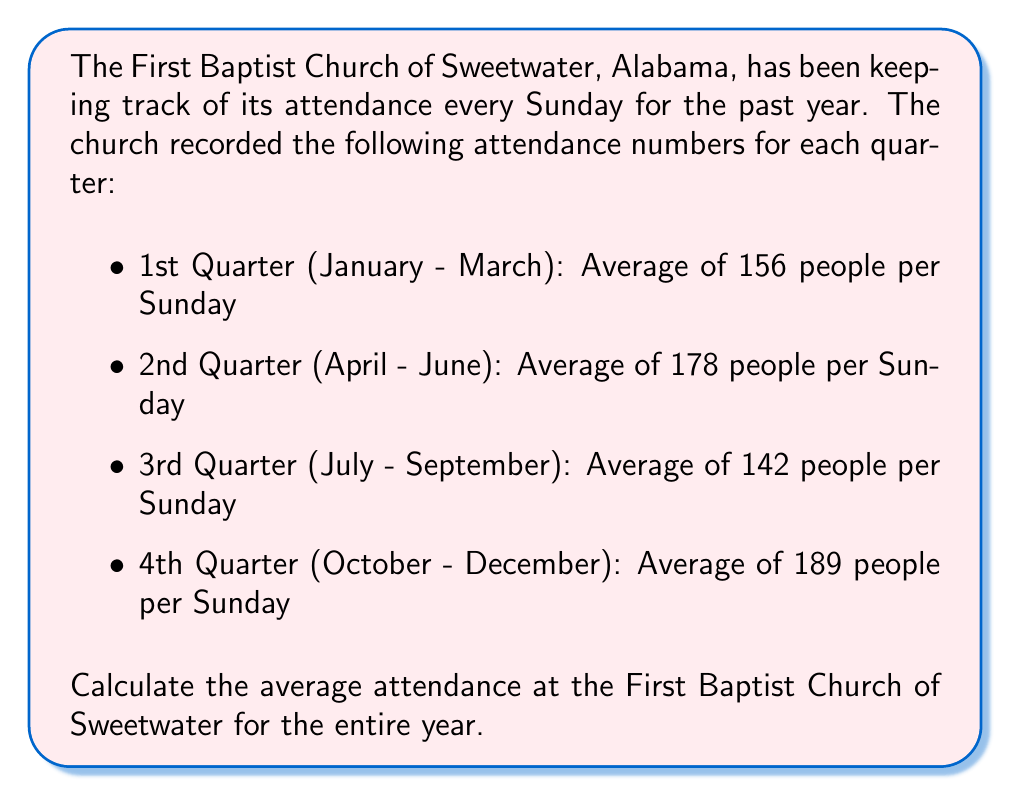Teach me how to tackle this problem. To calculate the average attendance for the entire year, we need to follow these steps:

1. Add up the average attendance for each quarter:
   $156 + 178 + 142 + 189 = 665$

2. Divide the sum by the number of quarters (4) to get the average:
   $$\text{Average Attendance} = \frac{\text{Sum of Quarterly Averages}}{\text{Number of Quarters}}$$
   
   $$\text{Average Attendance} = \frac{665}{4} = 166.25$$

3. Since we're dealing with people, we need to round to the nearest whole number:
   $166.25$ rounds to $166$

Therefore, the average attendance at the First Baptist Church of Sweetwater for the entire year was 166 people per Sunday.
Answer: 166 people 